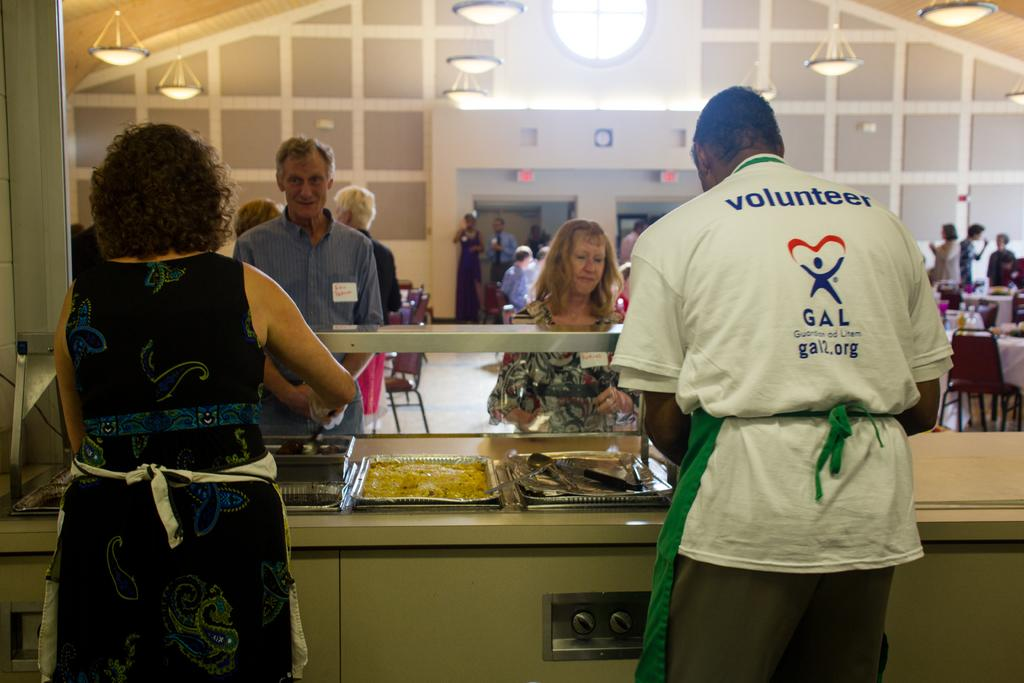How many people can be seen in the image? There are people in the image. What type of furniture is present in the image? There are tables and chairs in the image. What is in the bowls that are visible in the image? There are bowls with food in the image. What part of the room is visible in the image? The floor is visible in the image. What type of lighting is present in the image? There are lights in the image. What can be seen in the background of the image? There is a wall and boards in the background of the image. How many sons are present in the image? There is no mention of sons in the image; it only features people, tables, chairs, bowls with food, the floor, lights, a wall, and boards in the background. How many women can be seen in the image? There is no mention of gender in the image; it only features people. Are there any slaves depicted in the image? There is no mention of slavery or slaves in the image; it only features people, tables, chairs, bowls with food, the floor, lights, a wall, and boards in the background. 